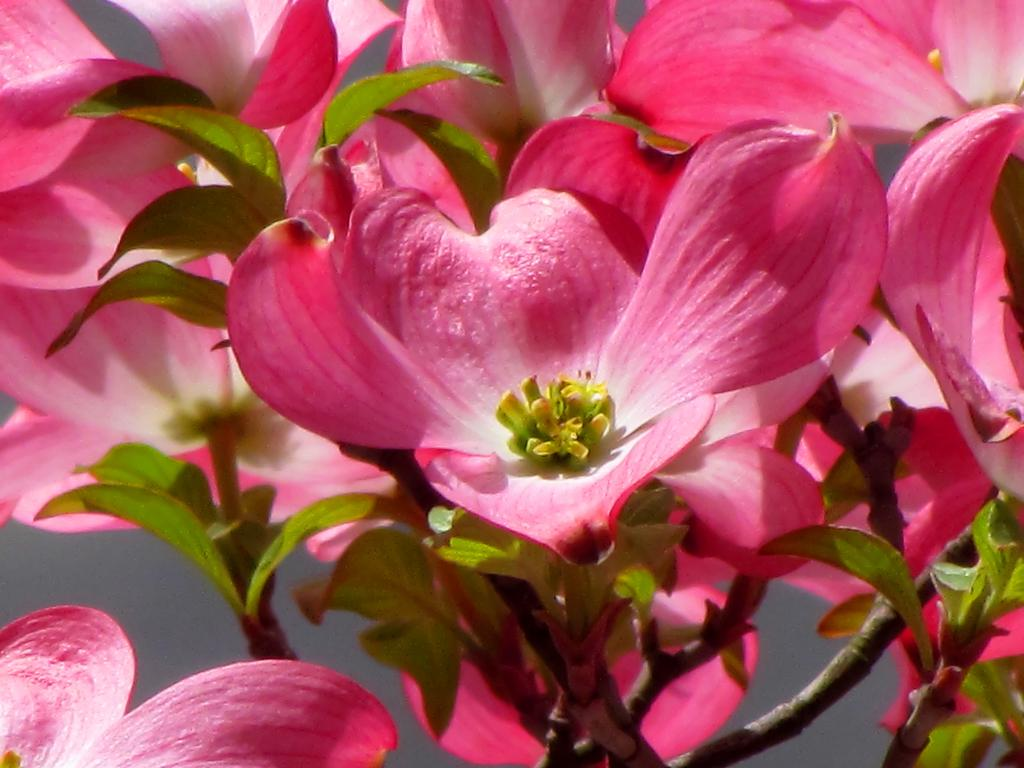What type of plant is visible in the image? There are flowers on a plant in the image. What can be found on the flowers in the image? Pollen grains are present on a flower in the image. Where is the pig located in the image? There is no pig present in the image. What type of tool is being used by the kitten in the image? There is no kitten or tool present in the image. 